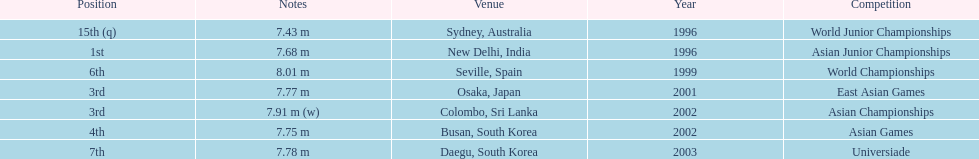What was the only competition where this competitor achieved 1st place? Asian Junior Championships. 